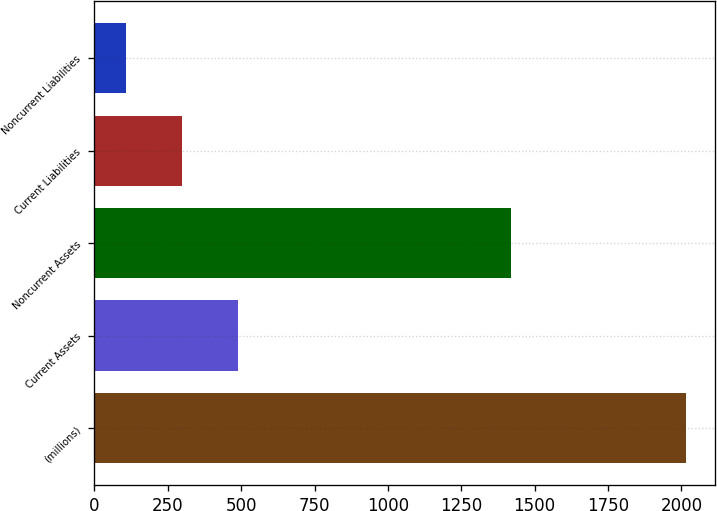<chart> <loc_0><loc_0><loc_500><loc_500><bar_chart><fcel>(millions)<fcel>Current Assets<fcel>Noncurrent Assets<fcel>Current Liabilities<fcel>Noncurrent Liabilities<nl><fcel>2015<fcel>489.4<fcel>1418<fcel>298.7<fcel>108<nl></chart> 